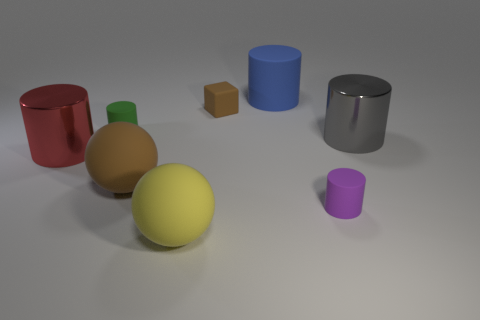How many things are either big metallic cylinders right of the red shiny cylinder or brown objects?
Make the answer very short. 3. The large red object on the left side of the large rubber cylinder has what shape?
Make the answer very short. Cylinder. Is the number of large brown matte things behind the red thing the same as the number of big rubber balls behind the big blue matte thing?
Offer a very short reply. Yes. There is a big object that is left of the big blue rubber cylinder and behind the brown matte sphere; what is its color?
Provide a succinct answer. Red. What is the material of the large object that is left of the brown matte thing that is on the left side of the block?
Make the answer very short. Metal. Is the yellow rubber sphere the same size as the green cylinder?
Provide a short and direct response. No. How many big things are either red metal spheres or blue things?
Make the answer very short. 1. How many large matte spheres are to the left of the large yellow ball?
Make the answer very short. 1. Are there more large metal things left of the cube than large cyan shiny things?
Keep it short and to the point. Yes. There is a large blue thing that is made of the same material as the tiny purple cylinder; what shape is it?
Keep it short and to the point. Cylinder. 